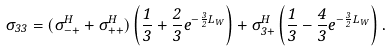<formula> <loc_0><loc_0><loc_500><loc_500>\sigma _ { 3 3 } = ( \sigma _ { - + } ^ { H } + \sigma _ { + + } ^ { H } ) \left ( \frac { 1 } { 3 } + \frac { 2 } { 3 } e ^ { - \frac { 3 } { 2 } L _ { W } } \right ) + \sigma _ { 3 + } ^ { H } \left ( \frac { 1 } { 3 } - \frac { 4 } { 3 } e ^ { - \frac { 3 } { 2 } L _ { W } } \right ) .</formula> 